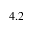<formula> <loc_0><loc_0><loc_500><loc_500>4 . 2</formula> 